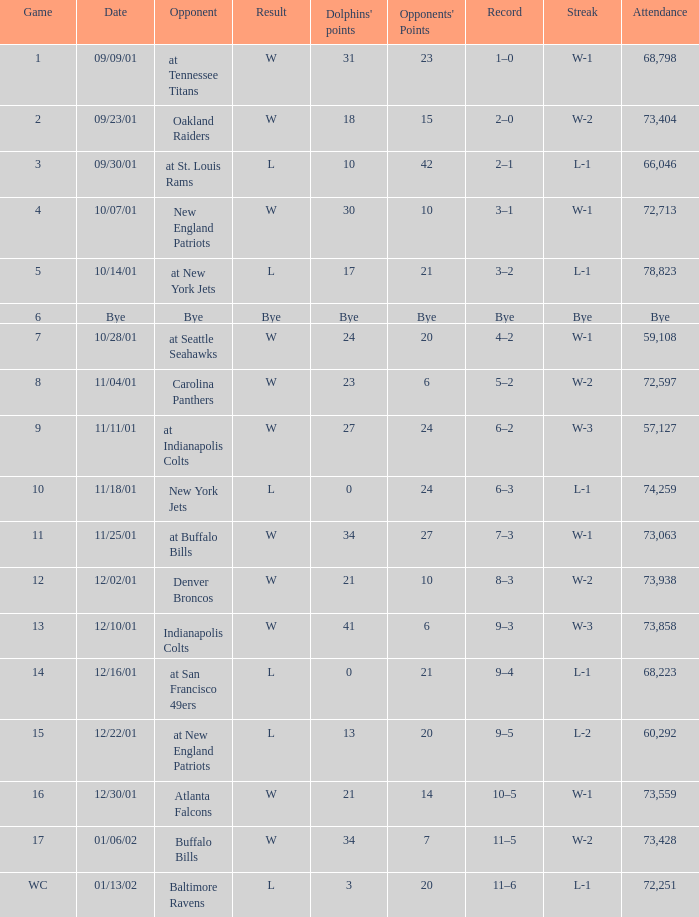What is the series of successive wins in game 2? W-2. 